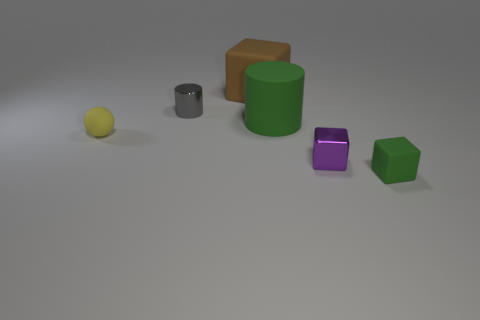Add 4 small blue cubes. How many objects exist? 10 Subtract all balls. How many objects are left? 5 Subtract all tiny green rubber cylinders. Subtract all balls. How many objects are left? 5 Add 5 gray shiny things. How many gray shiny things are left? 6 Add 4 small rubber spheres. How many small rubber spheres exist? 5 Subtract 0 green spheres. How many objects are left? 6 